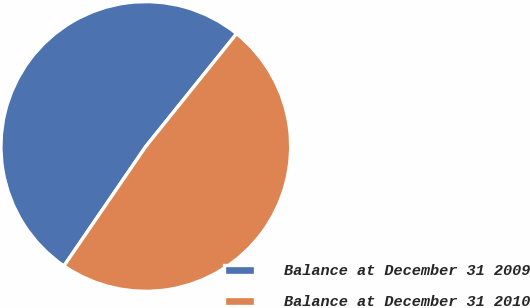Convert chart to OTSL. <chart><loc_0><loc_0><loc_500><loc_500><pie_chart><fcel>Balance at December 31 2009<fcel>Balance at December 31 2010<nl><fcel>51.22%<fcel>48.78%<nl></chart> 